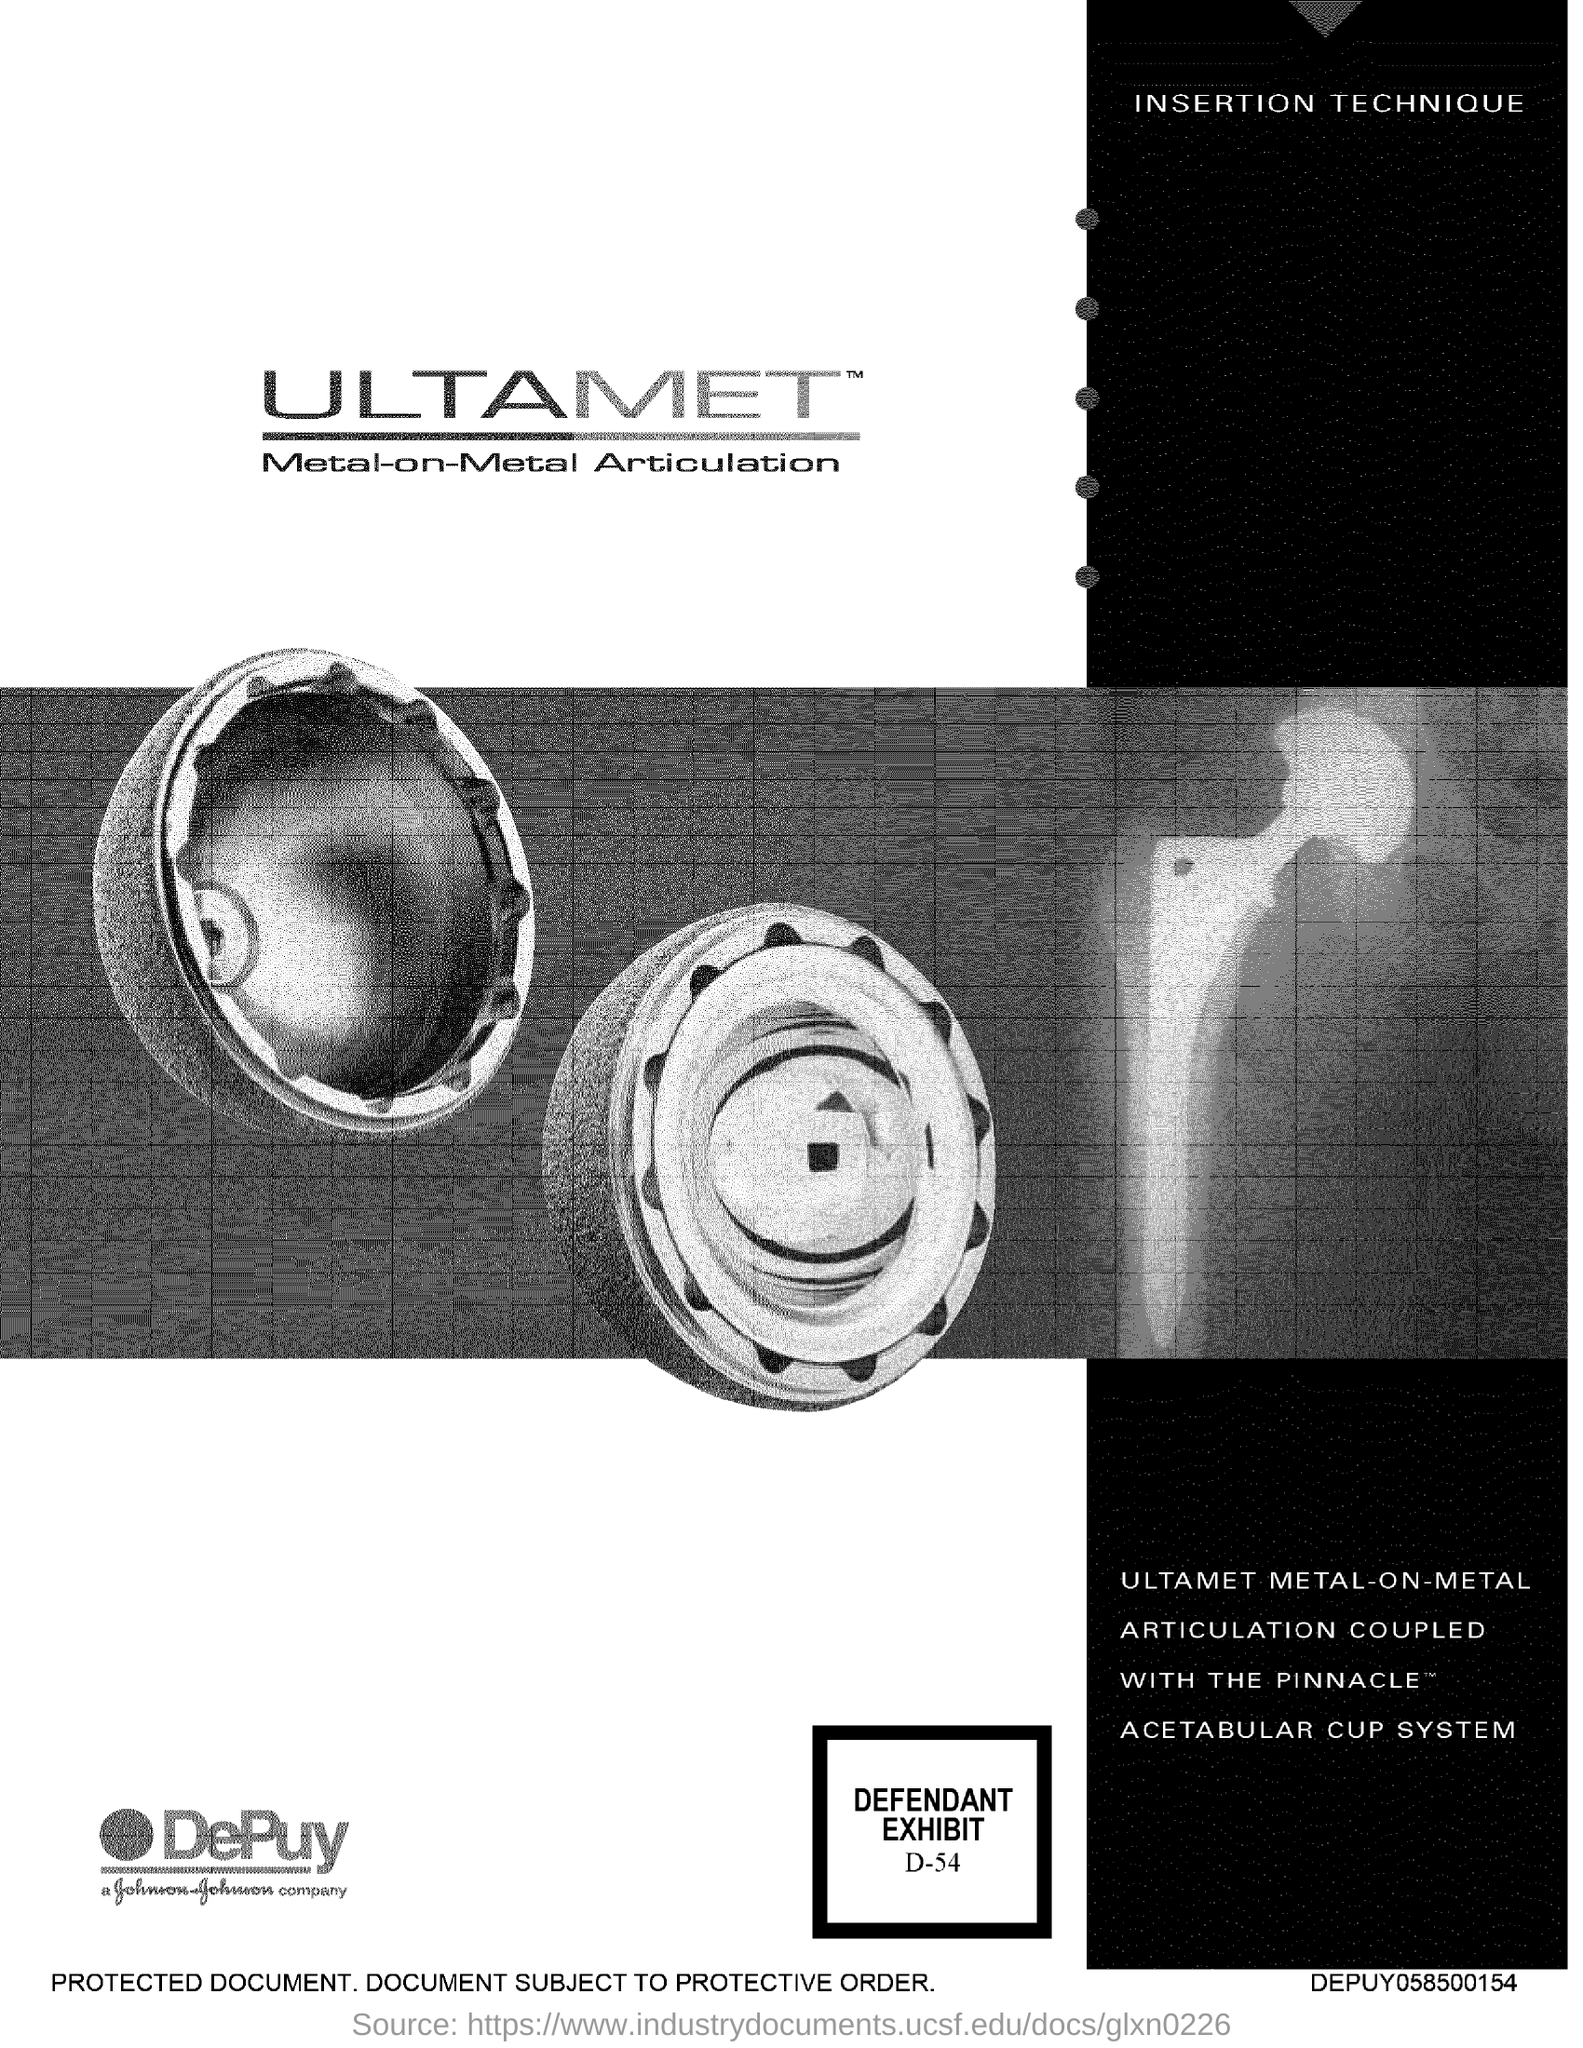What is the defendant exhibit number?
Give a very brief answer. D-54. 